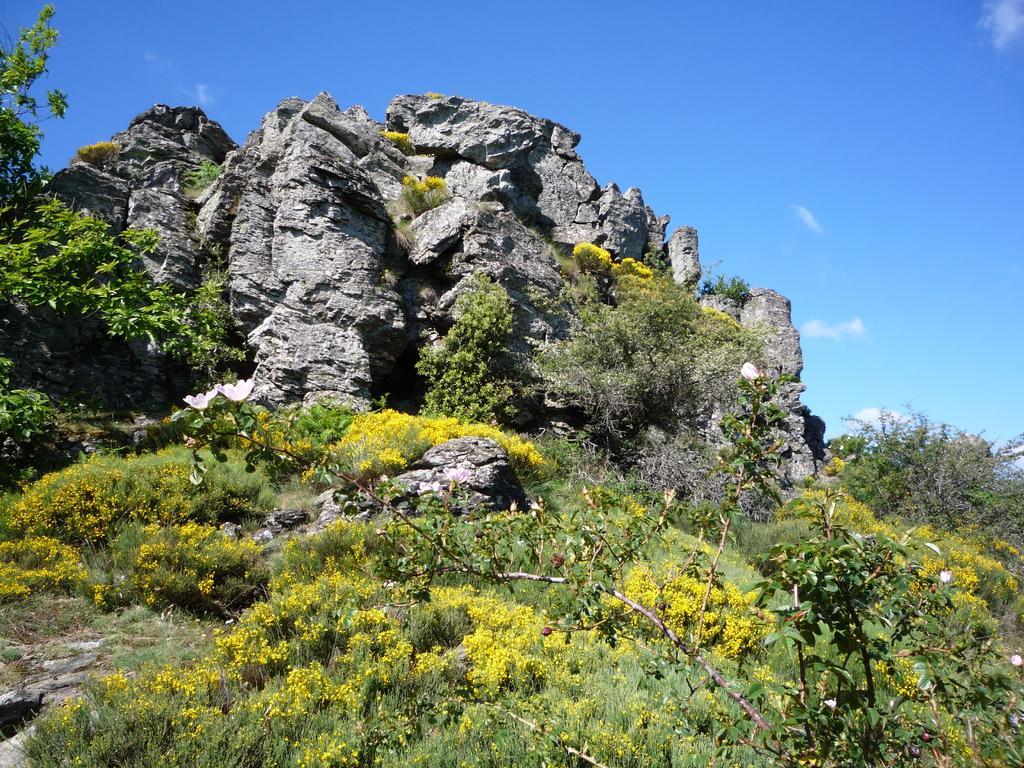Can you describe this image briefly? In this picture we can see plants, rocks, trees and in the background we can see the sky. 